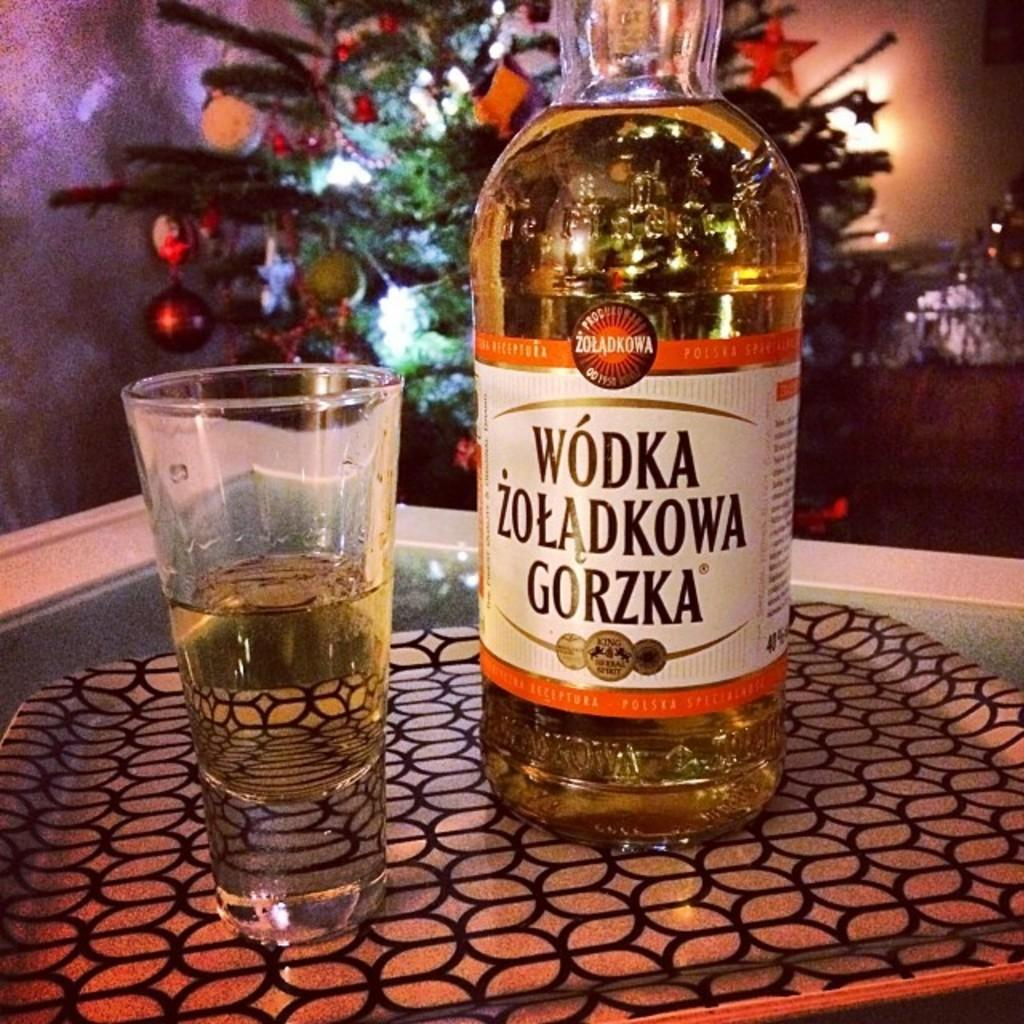Provide a one-sentence caption for the provided image. A label in a foreign language identifies a large bottle of vodka. 